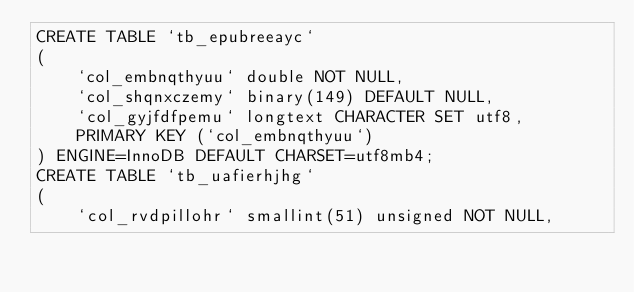<code> <loc_0><loc_0><loc_500><loc_500><_SQL_>CREATE TABLE `tb_epubreeayc`
(
    `col_embnqthyuu` double NOT NULL,
    `col_shqnxczemy` binary(149) DEFAULT NULL,
    `col_gyjfdfpemu` longtext CHARACTER SET utf8,
    PRIMARY KEY (`col_embnqthyuu`)
) ENGINE=InnoDB DEFAULT CHARSET=utf8mb4;
CREATE TABLE `tb_uafierhjhg`
(
    `col_rvdpillohr` smallint(51) unsigned NOT NULL,</code> 